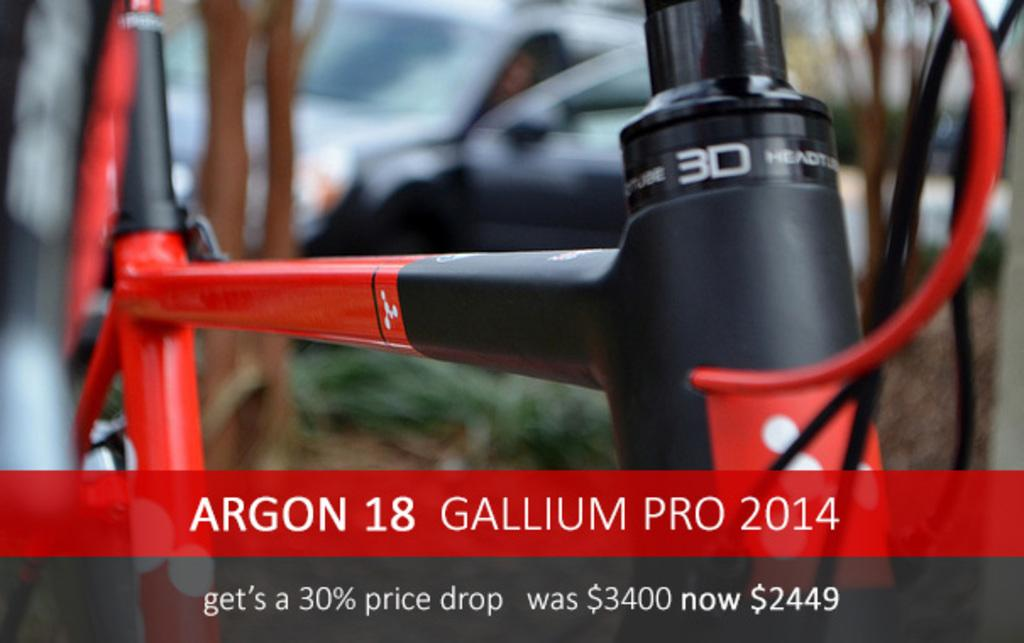What type of vehicle is partially visible in the image? There is a part of a bicycle in the image. Is there any text present on the bicycle? Yes, there is text written on the bicycle. What can be seen in the background of the image? There is a car visible in the background of the image. How does the bicycle contribute to the growth of the plants in the image? There are no plants present in the image, so the bicycle does not contribute to their growth. 